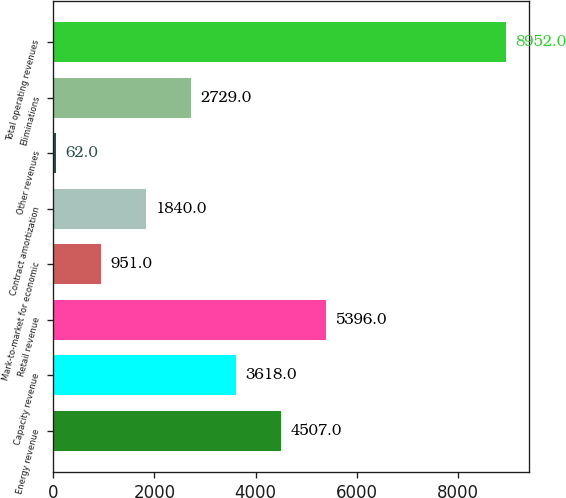Convert chart to OTSL. <chart><loc_0><loc_0><loc_500><loc_500><bar_chart><fcel>Energy revenue<fcel>Capacity revenue<fcel>Retail revenue<fcel>Mark-to-market for economic<fcel>Contract amortization<fcel>Other revenues<fcel>Eliminations<fcel>Total operating revenues<nl><fcel>4507<fcel>3618<fcel>5396<fcel>951<fcel>1840<fcel>62<fcel>2729<fcel>8952<nl></chart> 